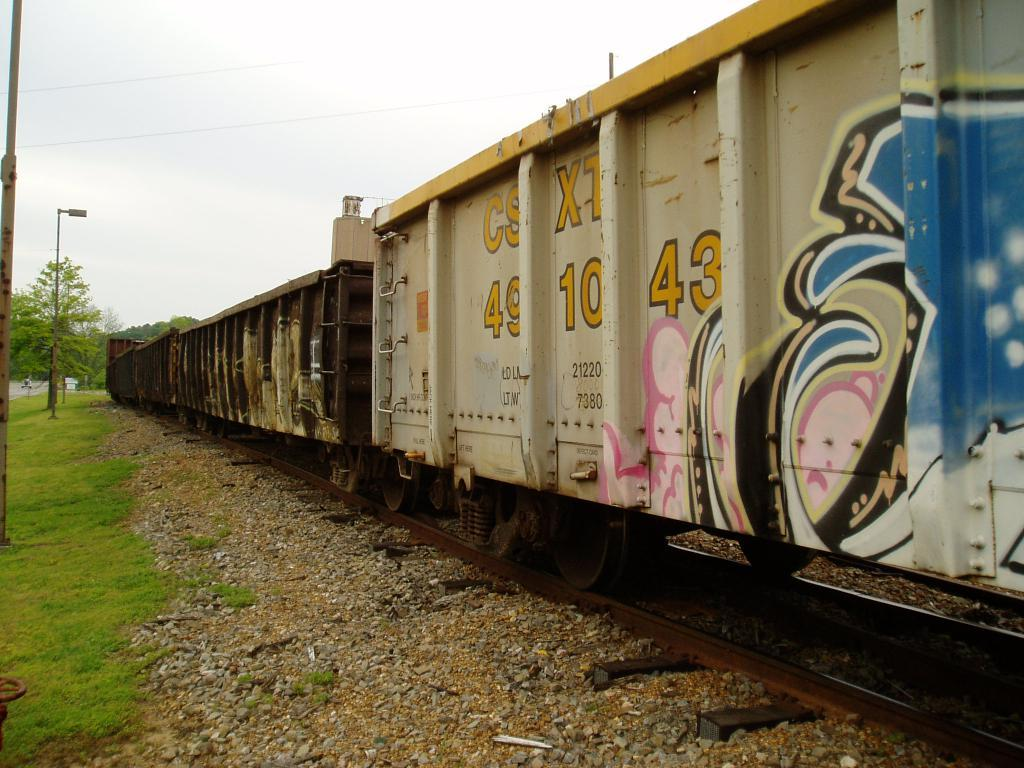What type of vehicle is in the image? There is a goods locomotive train in the image. What is the train positioned on? The train is on tracks. What type of vegetation can be seen in the image? There is grass on the surface beside the train, and there are trees in the image. What structures are present in the image? There are lamp posts in the image. How deep is the hole that the train is digging in the image? There is no hole present in the image; the train is on tracks. 